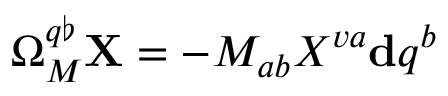<formula> <loc_0><loc_0><loc_500><loc_500>\Omega _ { M } ^ { q \flat } X = - M _ { a b } X ^ { v a d q ^ { b }</formula> 